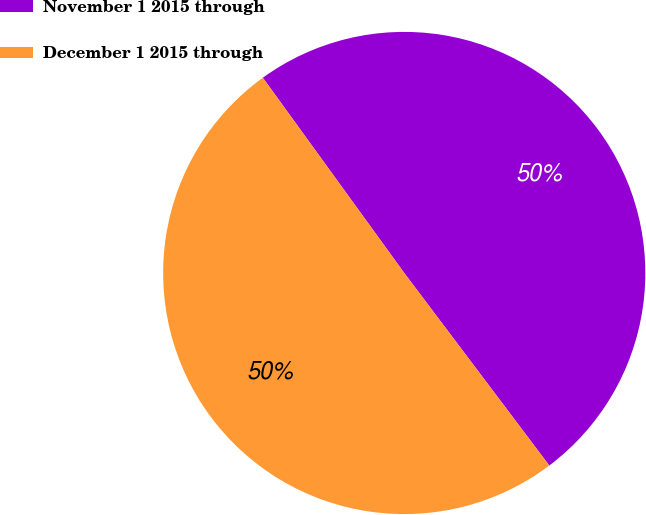<chart> <loc_0><loc_0><loc_500><loc_500><pie_chart><fcel>November 1 2015 through<fcel>December 1 2015 through<nl><fcel>49.7%<fcel>50.3%<nl></chart> 